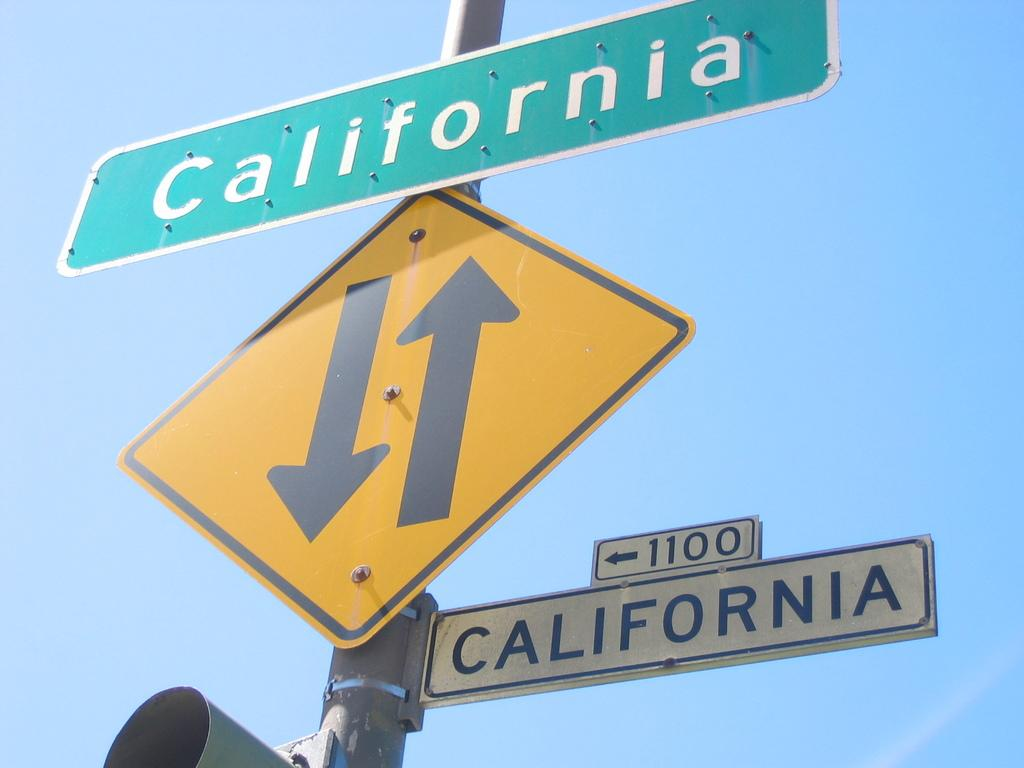<image>
Create a compact narrative representing the image presented. Traffic signs indicating a two way street on the 1100 block of California. 